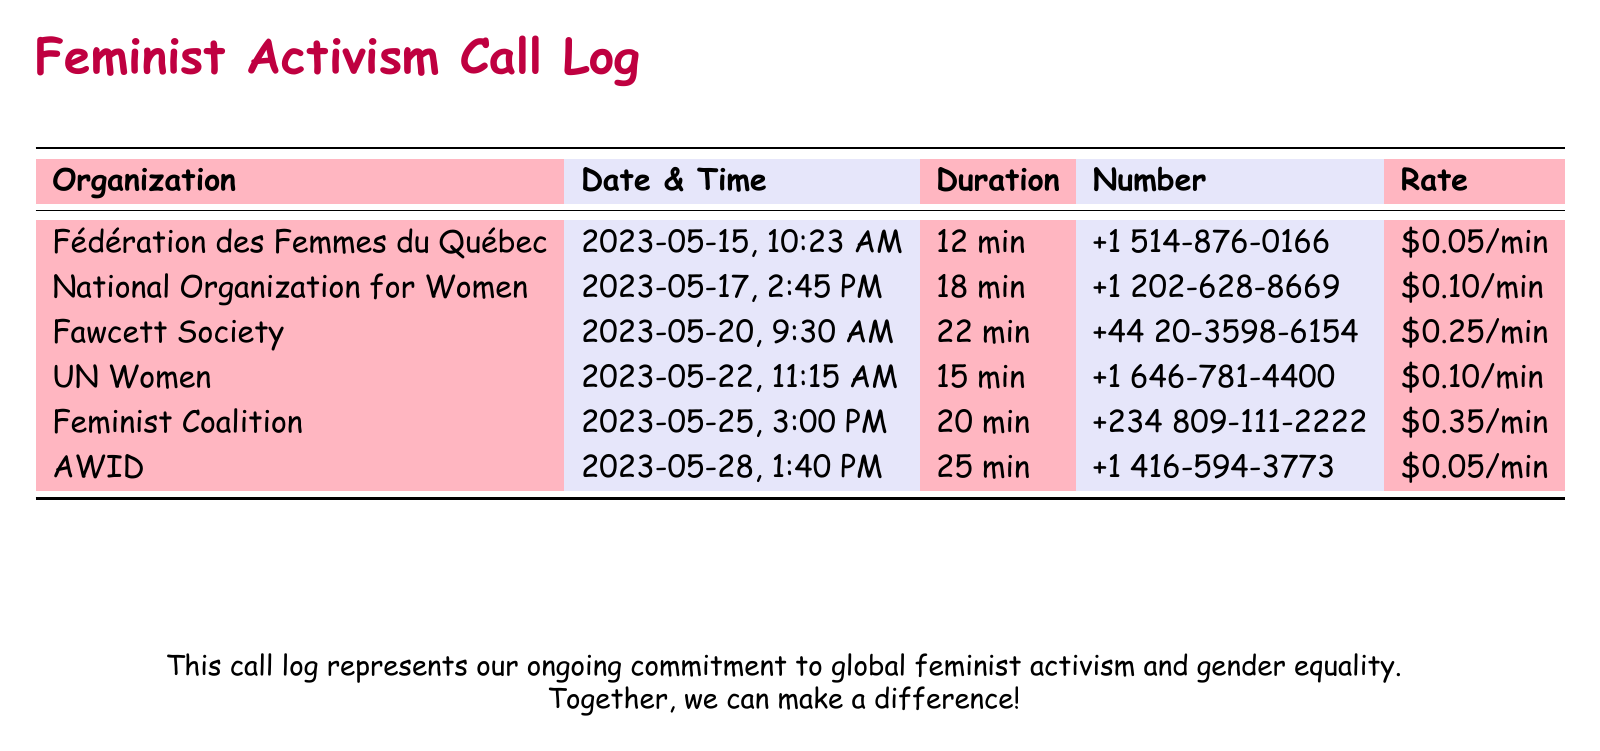what is the date of the call to the National Organization for Women? The date is specifically listed in the call log as 2023-05-17 for the National Organization for Women call.
Answer: 2023-05-17 what is the total duration of the call to the Fawcett Society? The duration is shown in the call log, which indicates that the call to the Fawcett Society lasted for 22 minutes.
Answer: 22 min what was the rate per minute for the call to UN Women? The call log provides the rate for the UN Women call, which is $0.10 per minute.
Answer: $0.10/min which organization had the highest call rate? By comparing the rates in the call log, the Feminist Coalition has the highest rate at $0.35 per minute.
Answer: Feminist Coalition how many minutes did the call to AWID last? The duration for the AWID call is detailed in the log, which states it lasted for 25 minutes.
Answer: 25 min what was the time of the call to Fédération des Femmes du Québec? The log specifies that the call to the Fédération des Femmes du Québec took place at 10:23 AM.
Answer: 10:23 AM 